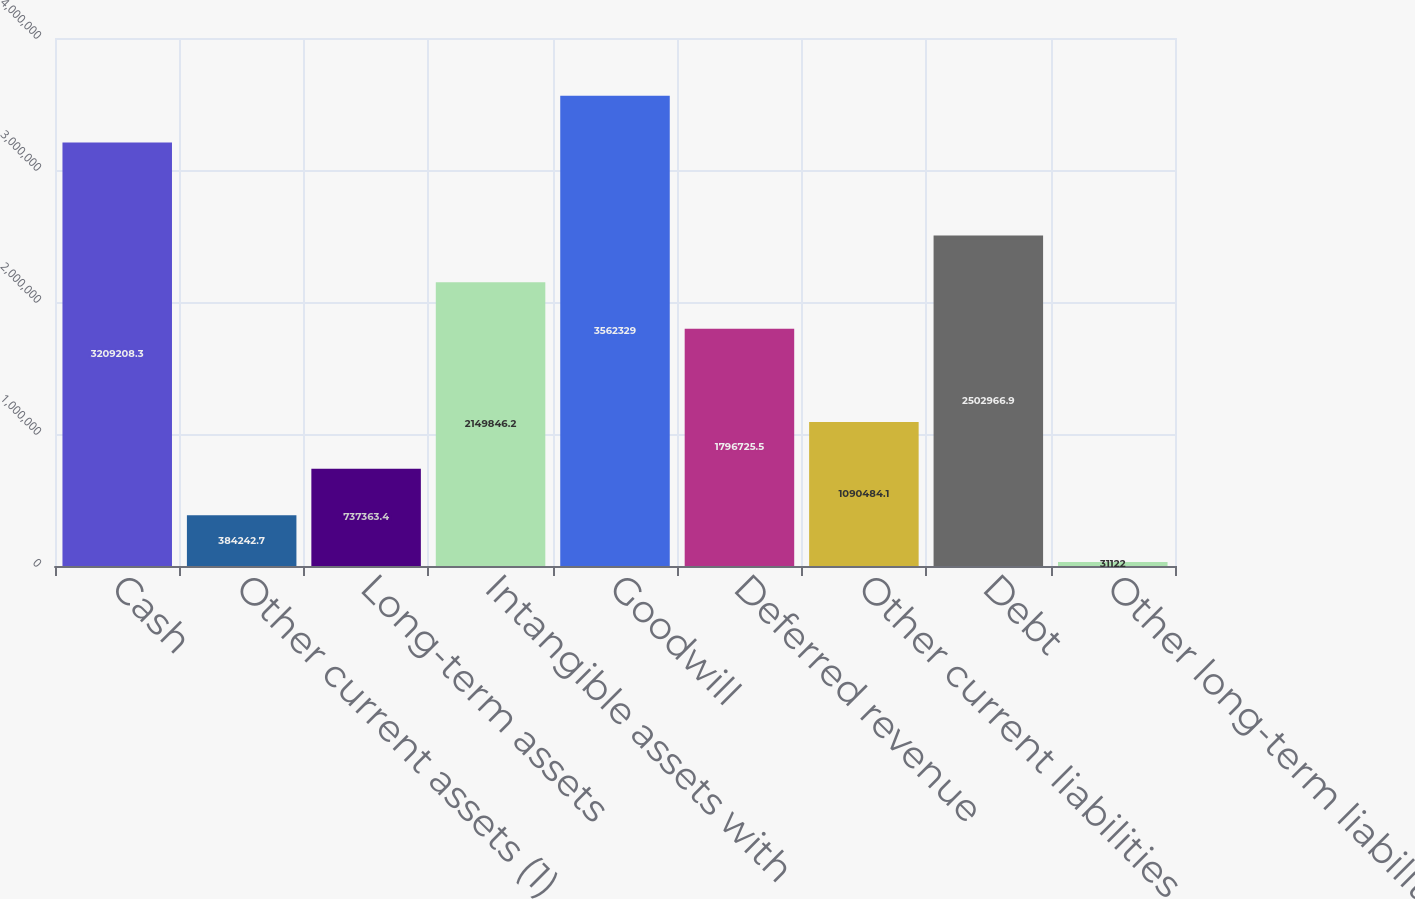<chart> <loc_0><loc_0><loc_500><loc_500><bar_chart><fcel>Cash<fcel>Other current assets (1)<fcel>Long-term assets<fcel>Intangible assets with<fcel>Goodwill<fcel>Deferred revenue<fcel>Other current liabilities<fcel>Debt<fcel>Other long-term liabilities<nl><fcel>3.20921e+06<fcel>384243<fcel>737363<fcel>2.14985e+06<fcel>3.56233e+06<fcel>1.79673e+06<fcel>1.09048e+06<fcel>2.50297e+06<fcel>31122<nl></chart> 